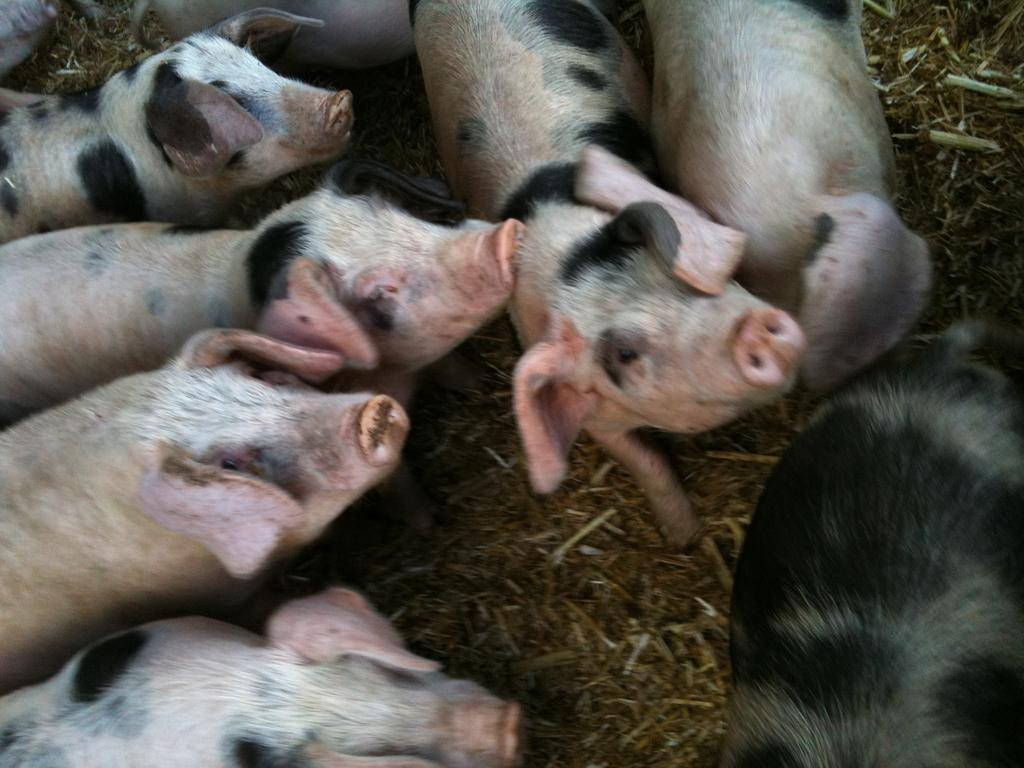What type of animals are present in the image? There are pigs in the image. Where are the pigs located in the image? The pigs are on the surface of the grass. What type of beds can be seen in the image? There are no beds present in the image; it features pigs on the grass. How do the pigs move around in the image? The pigs do not move around in the image; they are stationary on the grass. 